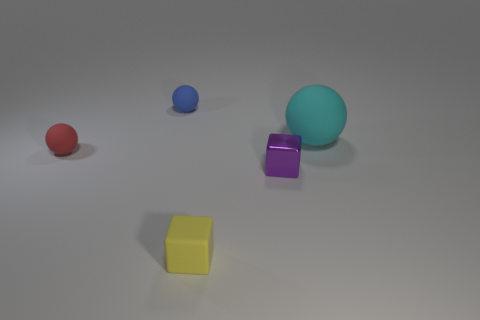Subtract all red balls. How many balls are left? 2 Add 2 large red shiny cylinders. How many objects exist? 7 Subtract all blue spheres. How many spheres are left? 2 Subtract all balls. How many objects are left? 2 Subtract 1 spheres. How many spheres are left? 2 Subtract all blue cubes. Subtract all cyan spheres. How many cubes are left? 2 Subtract all green spheres. How many yellow blocks are left? 1 Subtract all big yellow spheres. Subtract all large spheres. How many objects are left? 4 Add 3 large balls. How many large balls are left? 4 Add 2 big brown cubes. How many big brown cubes exist? 2 